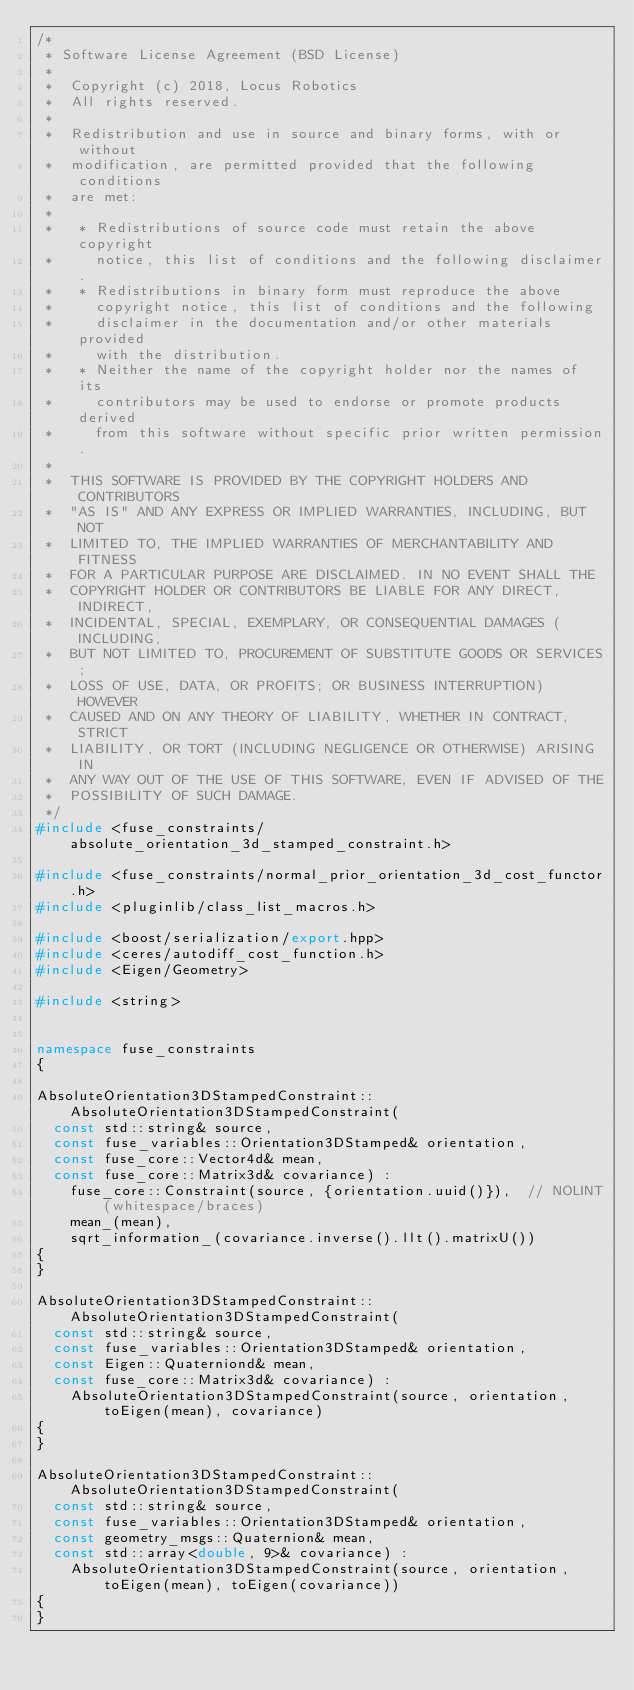Convert code to text. <code><loc_0><loc_0><loc_500><loc_500><_C++_>/*
 * Software License Agreement (BSD License)
 *
 *  Copyright (c) 2018, Locus Robotics
 *  All rights reserved.
 *
 *  Redistribution and use in source and binary forms, with or without
 *  modification, are permitted provided that the following conditions
 *  are met:
 *
 *   * Redistributions of source code must retain the above copyright
 *     notice, this list of conditions and the following disclaimer.
 *   * Redistributions in binary form must reproduce the above
 *     copyright notice, this list of conditions and the following
 *     disclaimer in the documentation and/or other materials provided
 *     with the distribution.
 *   * Neither the name of the copyright holder nor the names of its
 *     contributors may be used to endorse or promote products derived
 *     from this software without specific prior written permission.
 *
 *  THIS SOFTWARE IS PROVIDED BY THE COPYRIGHT HOLDERS AND CONTRIBUTORS
 *  "AS IS" AND ANY EXPRESS OR IMPLIED WARRANTIES, INCLUDING, BUT NOT
 *  LIMITED TO, THE IMPLIED WARRANTIES OF MERCHANTABILITY AND FITNESS
 *  FOR A PARTICULAR PURPOSE ARE DISCLAIMED. IN NO EVENT SHALL THE
 *  COPYRIGHT HOLDER OR CONTRIBUTORS BE LIABLE FOR ANY DIRECT, INDIRECT,
 *  INCIDENTAL, SPECIAL, EXEMPLARY, OR CONSEQUENTIAL DAMAGES (INCLUDING,
 *  BUT NOT LIMITED TO, PROCUREMENT OF SUBSTITUTE GOODS OR SERVICES;
 *  LOSS OF USE, DATA, OR PROFITS; OR BUSINESS INTERRUPTION) HOWEVER
 *  CAUSED AND ON ANY THEORY OF LIABILITY, WHETHER IN CONTRACT, STRICT
 *  LIABILITY, OR TORT (INCLUDING NEGLIGENCE OR OTHERWISE) ARISING IN
 *  ANY WAY OUT OF THE USE OF THIS SOFTWARE, EVEN IF ADVISED OF THE
 *  POSSIBILITY OF SUCH DAMAGE.
 */
#include <fuse_constraints/absolute_orientation_3d_stamped_constraint.h>

#include <fuse_constraints/normal_prior_orientation_3d_cost_functor.h>
#include <pluginlib/class_list_macros.h>

#include <boost/serialization/export.hpp>
#include <ceres/autodiff_cost_function.h>
#include <Eigen/Geometry>

#include <string>


namespace fuse_constraints
{

AbsoluteOrientation3DStampedConstraint::AbsoluteOrientation3DStampedConstraint(
  const std::string& source,
  const fuse_variables::Orientation3DStamped& orientation,
  const fuse_core::Vector4d& mean,
  const fuse_core::Matrix3d& covariance) :
    fuse_core::Constraint(source, {orientation.uuid()}),  // NOLINT(whitespace/braces)
    mean_(mean),
    sqrt_information_(covariance.inverse().llt().matrixU())
{
}

AbsoluteOrientation3DStampedConstraint::AbsoluteOrientation3DStampedConstraint(
  const std::string& source,
  const fuse_variables::Orientation3DStamped& orientation,
  const Eigen::Quaterniond& mean,
  const fuse_core::Matrix3d& covariance) :
    AbsoluteOrientation3DStampedConstraint(source, orientation, toEigen(mean), covariance)
{
}

AbsoluteOrientation3DStampedConstraint::AbsoluteOrientation3DStampedConstraint(
  const std::string& source,
  const fuse_variables::Orientation3DStamped& orientation,
  const geometry_msgs::Quaternion& mean,
  const std::array<double, 9>& covariance) :
    AbsoluteOrientation3DStampedConstraint(source, orientation, toEigen(mean), toEigen(covariance))
{
}
</code> 